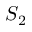Convert formula to latex. <formula><loc_0><loc_0><loc_500><loc_500>S _ { 2 }</formula> 